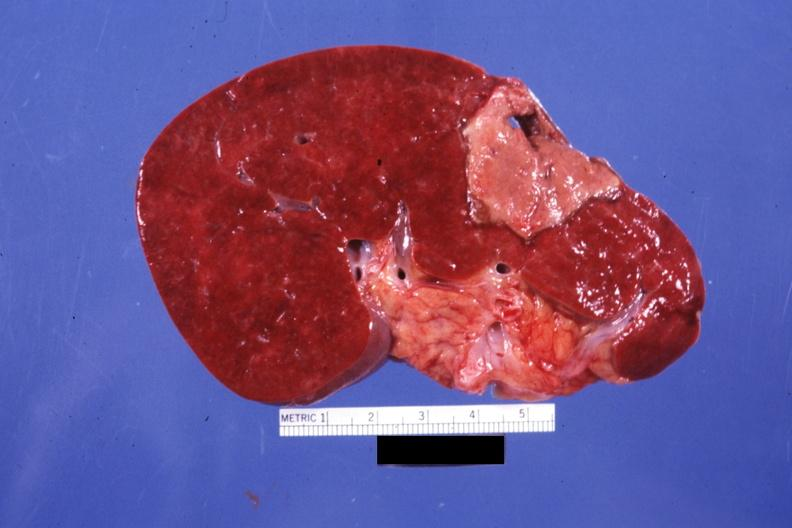s fibroma present?
Answer the question using a single word or phrase. No 